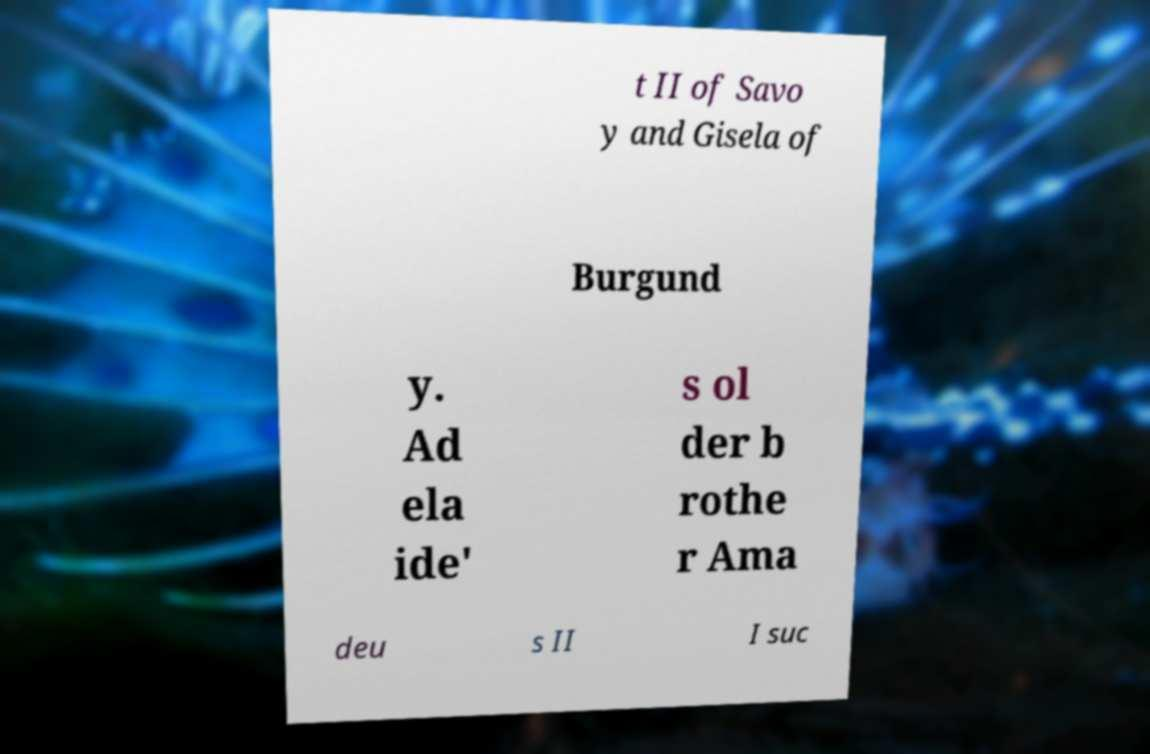Could you assist in decoding the text presented in this image and type it out clearly? t II of Savo y and Gisela of Burgund y. Ad ela ide' s ol der b rothe r Ama deu s II I suc 